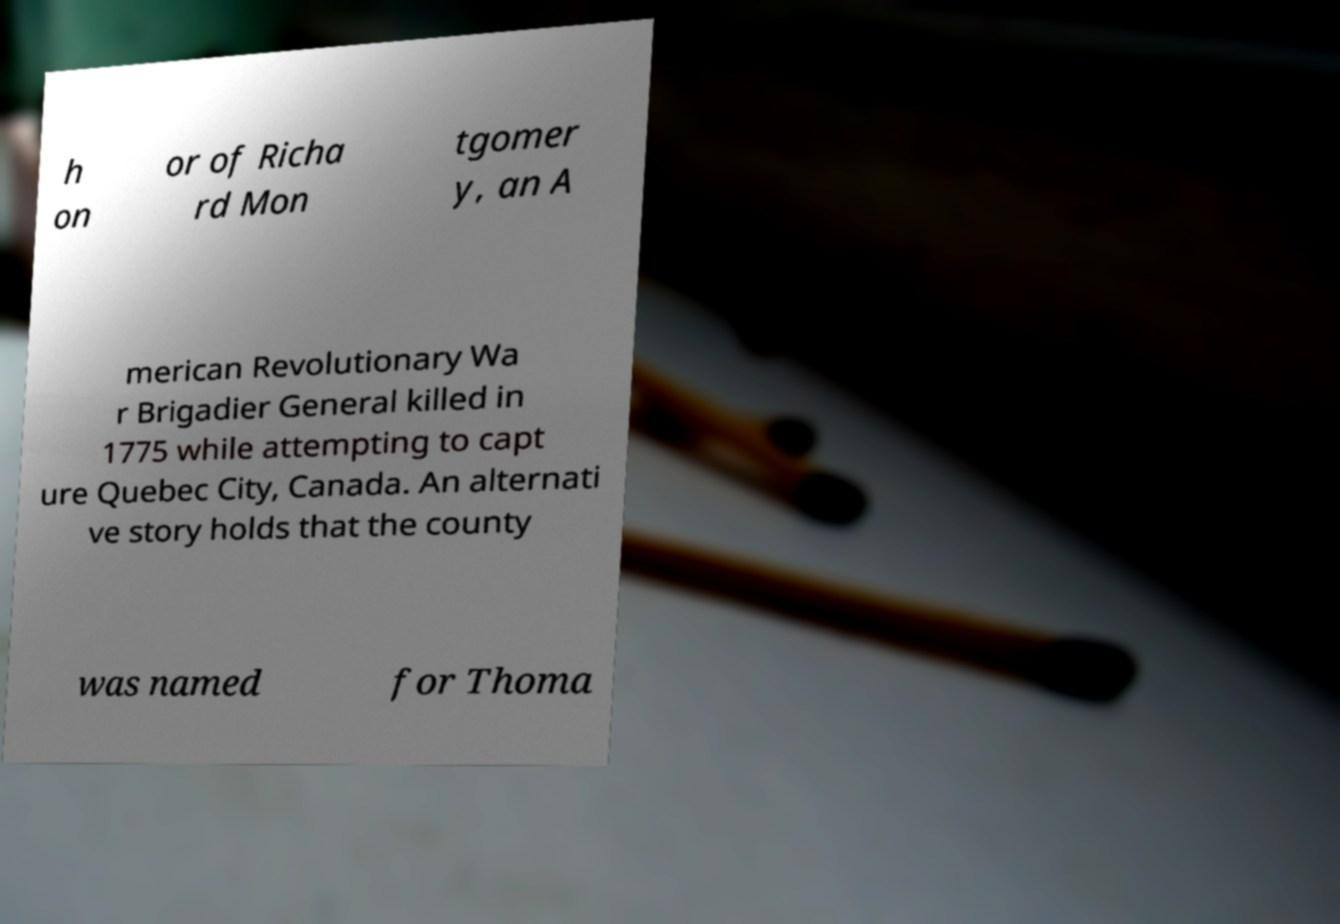What messages or text are displayed in this image? I need them in a readable, typed format. h on or of Richa rd Mon tgomer y, an A merican Revolutionary Wa r Brigadier General killed in 1775 while attempting to capt ure Quebec City, Canada. An alternati ve story holds that the county was named for Thoma 